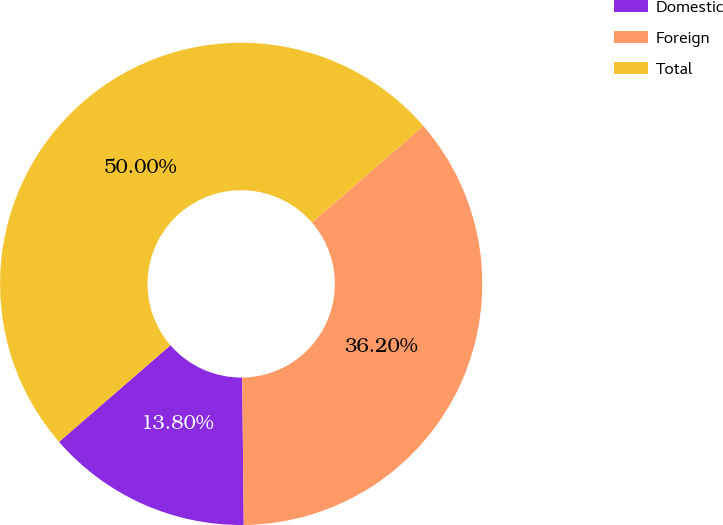Convert chart to OTSL. <chart><loc_0><loc_0><loc_500><loc_500><pie_chart><fcel>Domestic<fcel>Foreign<fcel>Total<nl><fcel>13.8%<fcel>36.2%<fcel>50.0%<nl></chart> 